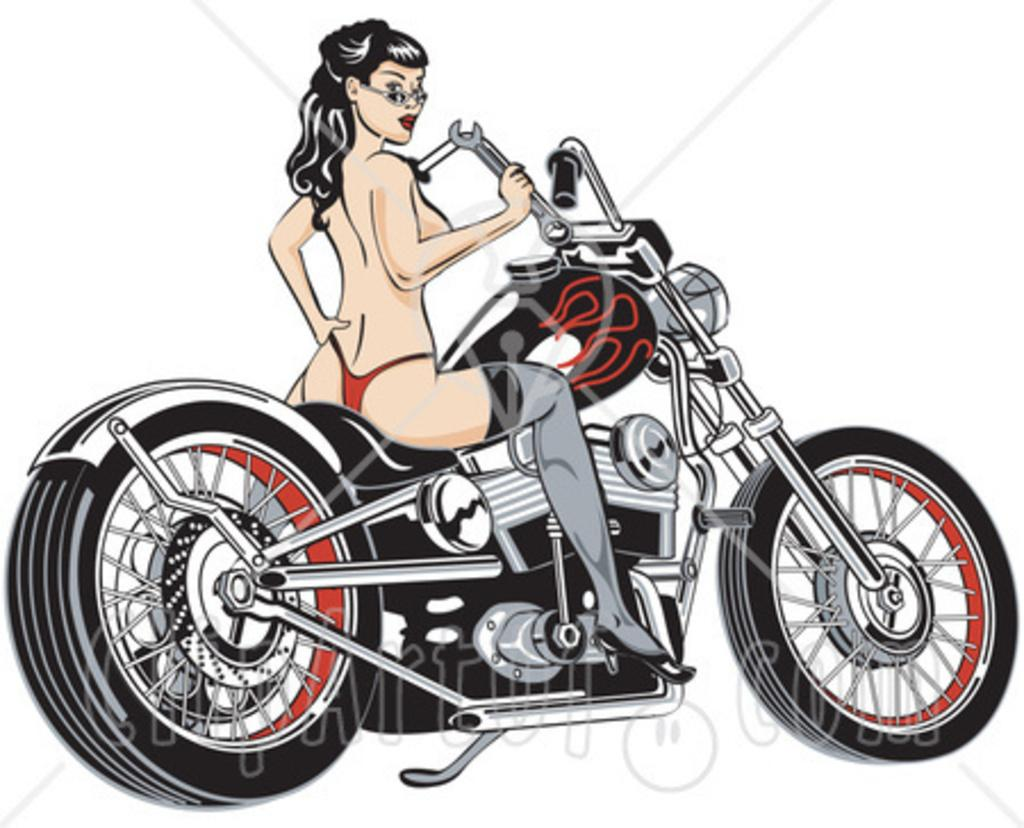What type of image is being described? The image is animated. What is the person in the image doing? The person is sitting on a motorbike. What is the color of the background in the image? The background in the image is white. Can you see any bones in the image? There are no bones present in the image. What type of whip is being used by the person on the motorbike? There is no whip present in the image; the person is simply sitting on the motorbike. 